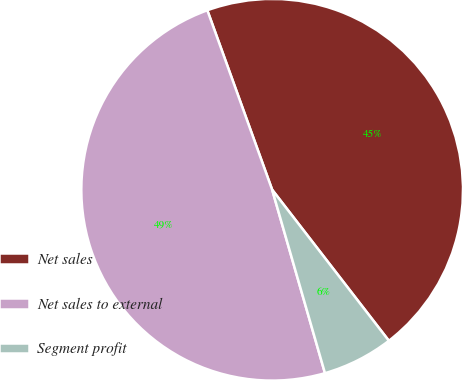<chart> <loc_0><loc_0><loc_500><loc_500><pie_chart><fcel>Net sales<fcel>Net sales to external<fcel>Segment profit<nl><fcel>45.05%<fcel>48.95%<fcel>6.01%<nl></chart> 